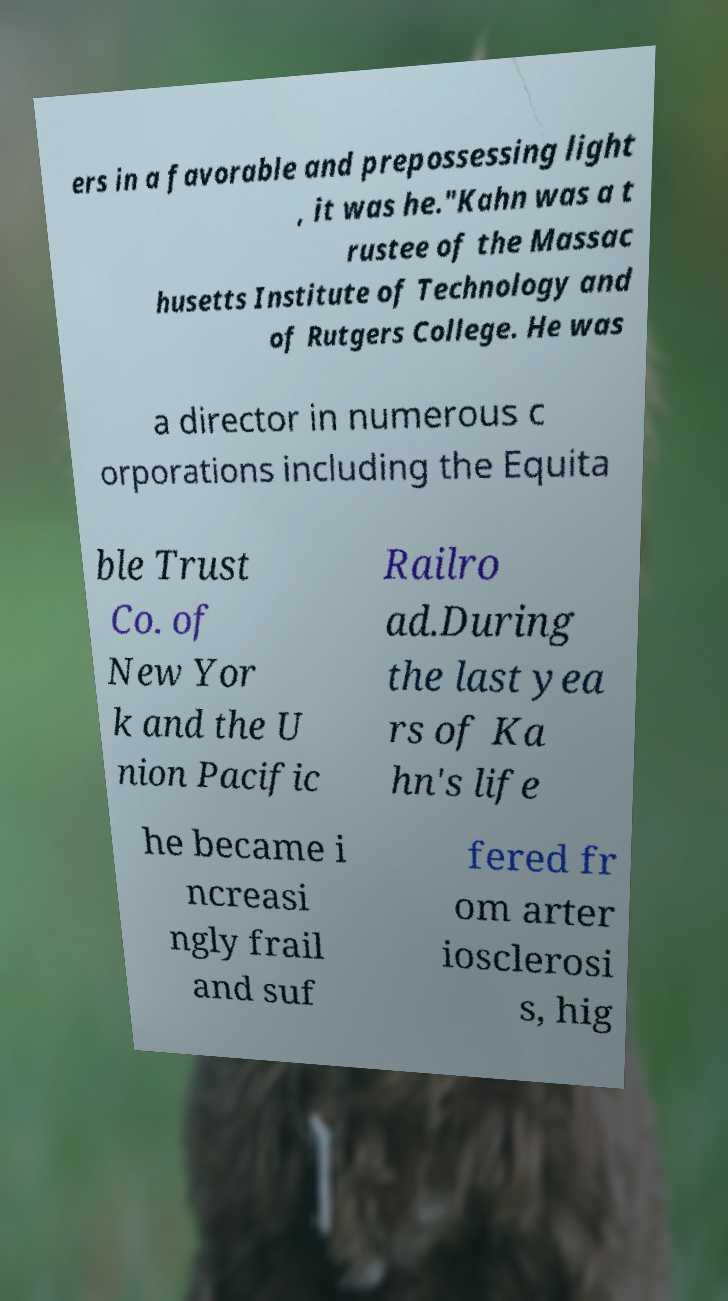Please read and relay the text visible in this image. What does it say? ers in a favorable and prepossessing light , it was he."Kahn was a t rustee of the Massac husetts Institute of Technology and of Rutgers College. He was a director in numerous c orporations including the Equita ble Trust Co. of New Yor k and the U nion Pacific Railro ad.During the last yea rs of Ka hn's life he became i ncreasi ngly frail and suf fered fr om arter iosclerosi s, hig 